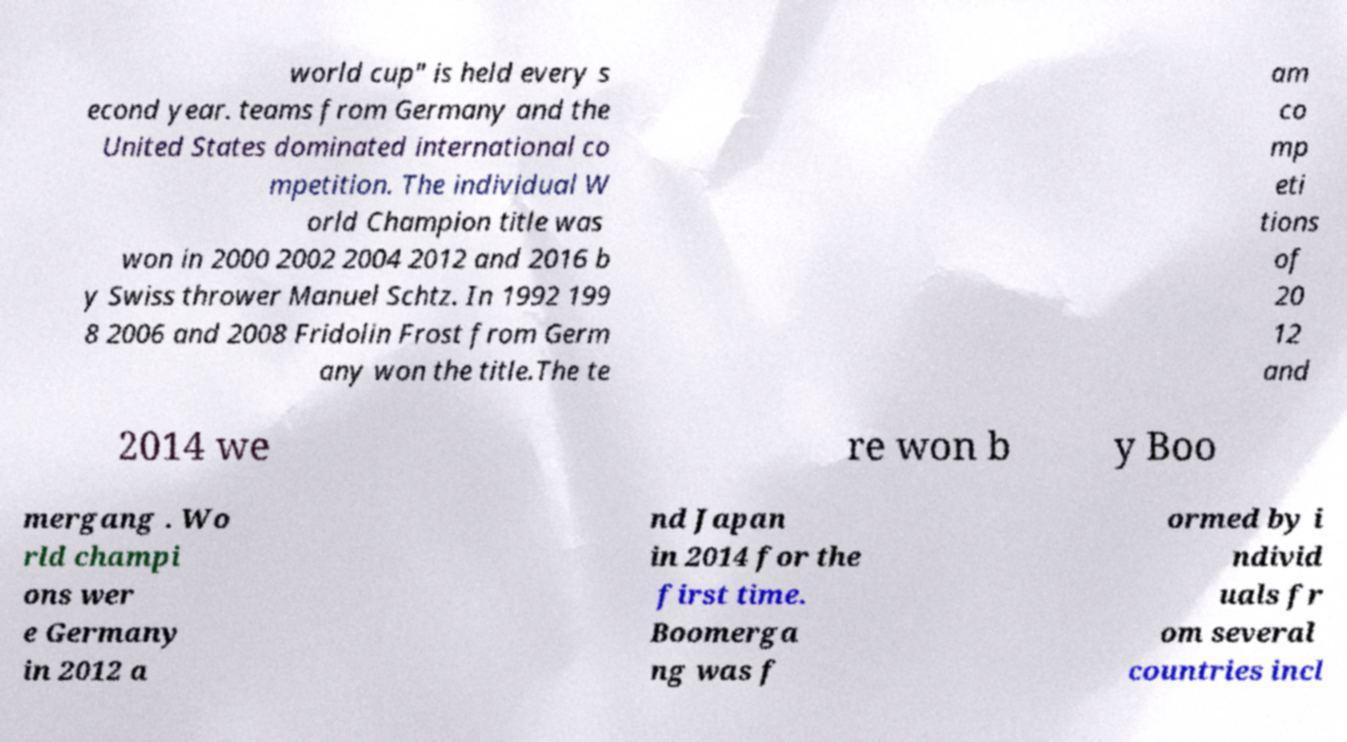What messages or text are displayed in this image? I need them in a readable, typed format. world cup" is held every s econd year. teams from Germany and the United States dominated international co mpetition. The individual W orld Champion title was won in 2000 2002 2004 2012 and 2016 b y Swiss thrower Manuel Schtz. In 1992 199 8 2006 and 2008 Fridolin Frost from Germ any won the title.The te am co mp eti tions of 20 12 and 2014 we re won b y Boo mergang . Wo rld champi ons wer e Germany in 2012 a nd Japan in 2014 for the first time. Boomerga ng was f ormed by i ndivid uals fr om several countries incl 